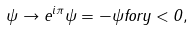<formula> <loc_0><loc_0><loc_500><loc_500>\psi \to e ^ { i \pi } \psi = - \psi f o r y < 0 ,</formula> 